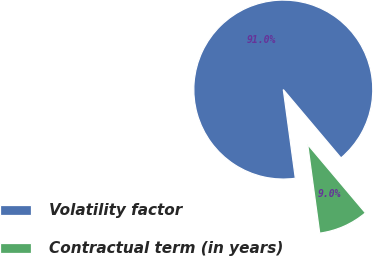Convert chart. <chart><loc_0><loc_0><loc_500><loc_500><pie_chart><fcel>Volatility factor<fcel>Contractual term (in years)<nl><fcel>90.99%<fcel>9.01%<nl></chart> 